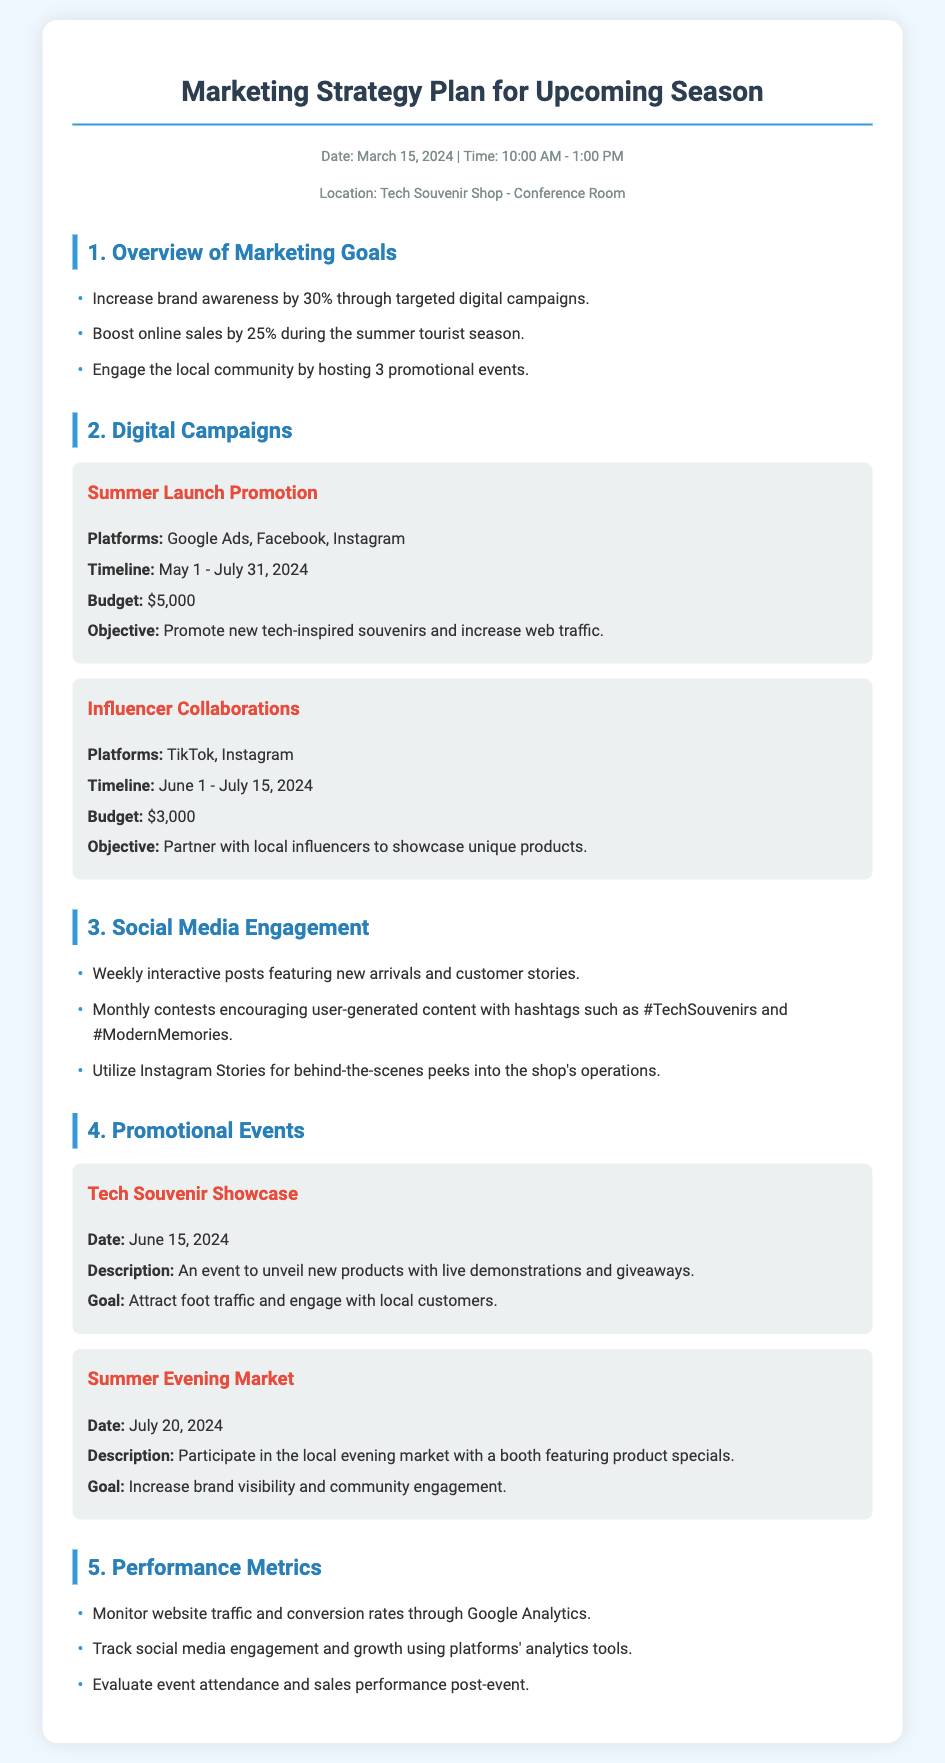What is the date of the marketing strategy plan? The date of the marketing strategy plan is mentioned in the header information.
Answer: March 15, 2024 What is the budget for the Summer Launch Promotion? The budget for the Summer Launch Promotion is clearly stated within the digital campaigns section.
Answer: $5,000 What platforms will be used for Influencer Collaborations? Platforms for Influencer Collaborations are specified along with the campaign details.
Answer: TikTok, Instagram How many promotional events are planned for the season? The number of promotional events is indicated in the marketing goals.
Answer: 3 When is the Tech Souvenir Showcase event scheduled? The date for the Tech Souvenir Showcase is provided in the events section.
Answer: June 15, 2024 What is the objective of the Summer Launch Promotion? The objective is explicitly detailed in the description of the digital campaign.
Answer: Promote new tech-inspired souvenirs and increase web traffic Which social media platform will be utilized for behind-the-scenes peeks? The specific platform for behind-the-scenes content is mentioned in the social media engagement section.
Answer: Instagram Stories How is the effectiveness of social media engagement tracked? The method for tracking social media engagement is noted in the performance metrics section.
Answer: Platforms' analytics tools What is the goal of participating in the Summer Evening Market? The goal for the event participation is outlined in the event description.
Answer: Increase brand visibility and community engagement 